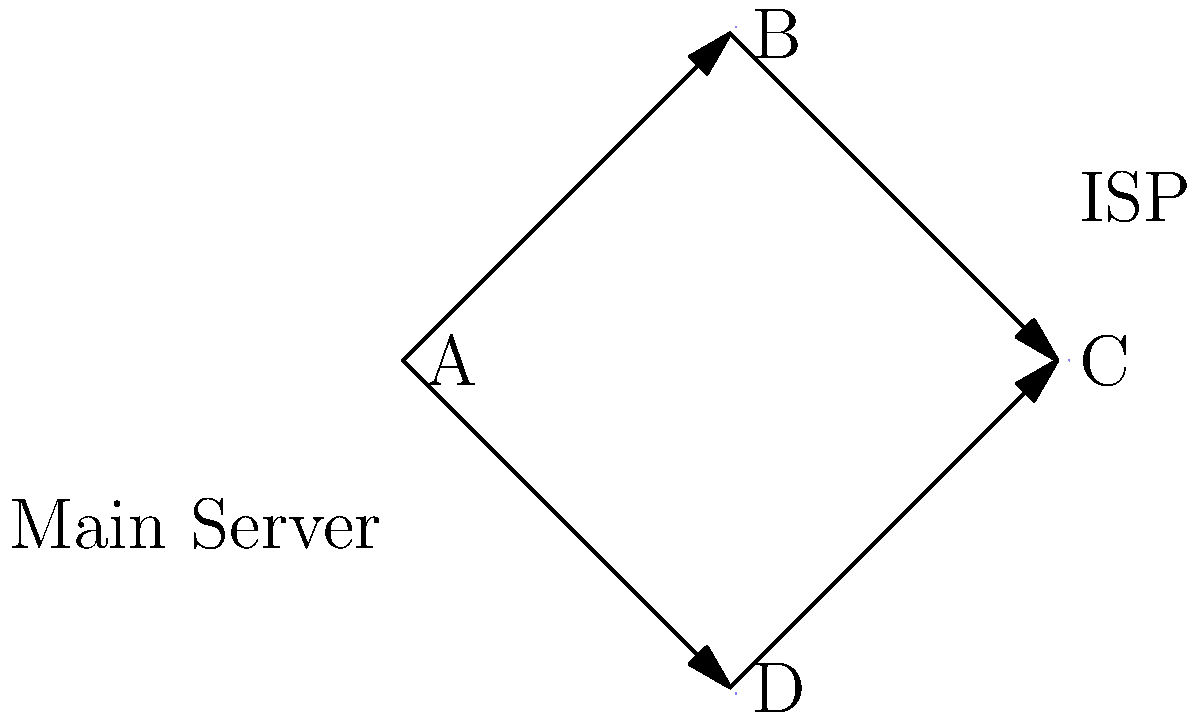As a city council member, you're evaluating a proposal to improve internet connectivity across the city. The current network topology is shown above, where A is the main server, B and D are distribution nodes, and C represents the ISP connection. If node B fails, what percentage of the city would lose internet access, assuming equal distribution of users among nodes B and D? To solve this problem, we need to analyze the network topology and understand the impact of node B failing:

1. Identify the network structure:
   - Node A is the main server, connected to both B and D.
   - Nodes B and D are distribution nodes.
   - Node C is the ISP connection, connected to both B and D.

2. Assess the impact of node B failing:
   - If B fails, the connection A-B-C is lost.
   - However, the connection A-D-C remains intact.

3. Calculate the percentage of users affected:
   - We're told that users are equally distributed among nodes B and D.
   - This means each node serves 50% of the city's users.
   - If node B fails, only the users connected through B will lose access.

4. Determine the final result:
   - Since B serves 50% of the users, and only B is affected, 50% of the city would lose internet access.

The topology shows redundancy in the network, which is a good design for maintaining connectivity in case of partial failures. This redundancy ensures that not all users lose connection if one distribution node fails.
Answer: 50% 